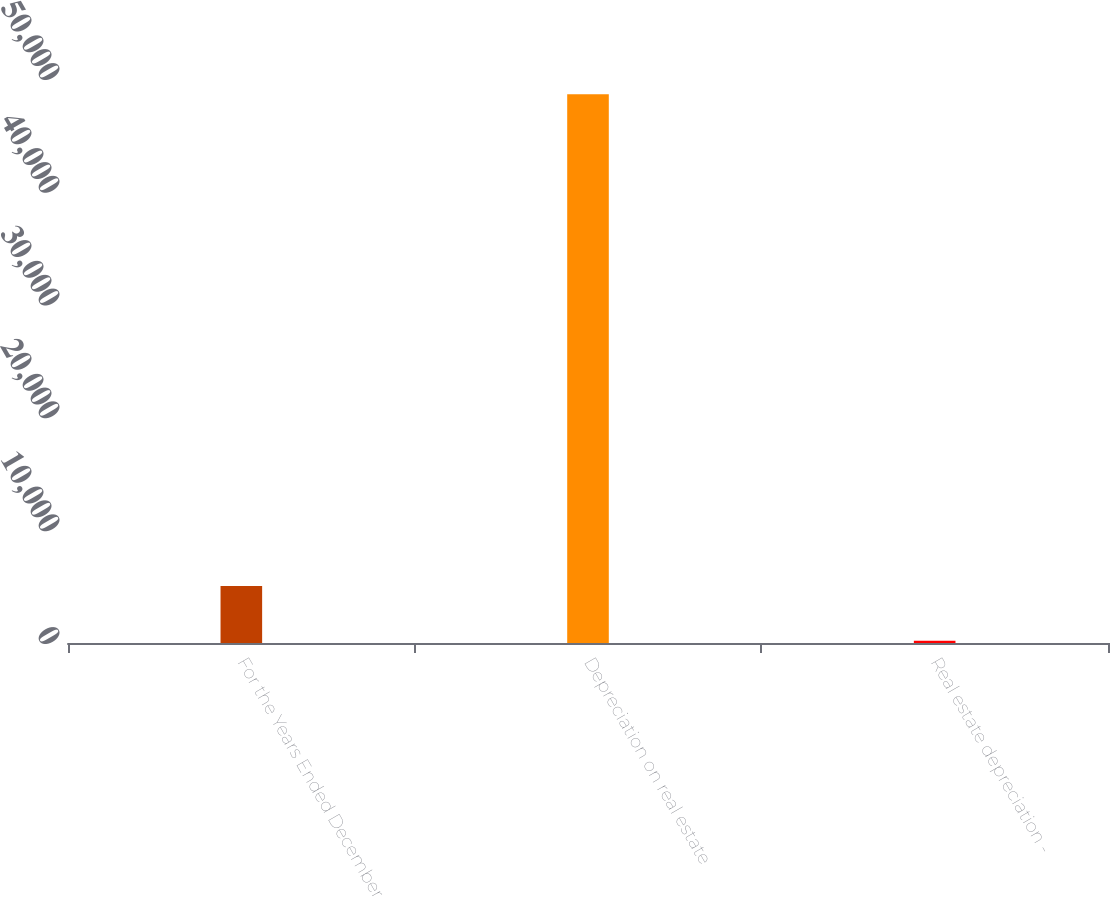Convert chart to OTSL. <chart><loc_0><loc_0><loc_500><loc_500><bar_chart><fcel>For the Years Ended December<fcel>Depreciation on real estate<fcel>Real estate depreciation -<nl><fcel>5047.4<fcel>48647<fcel>203<nl></chart> 